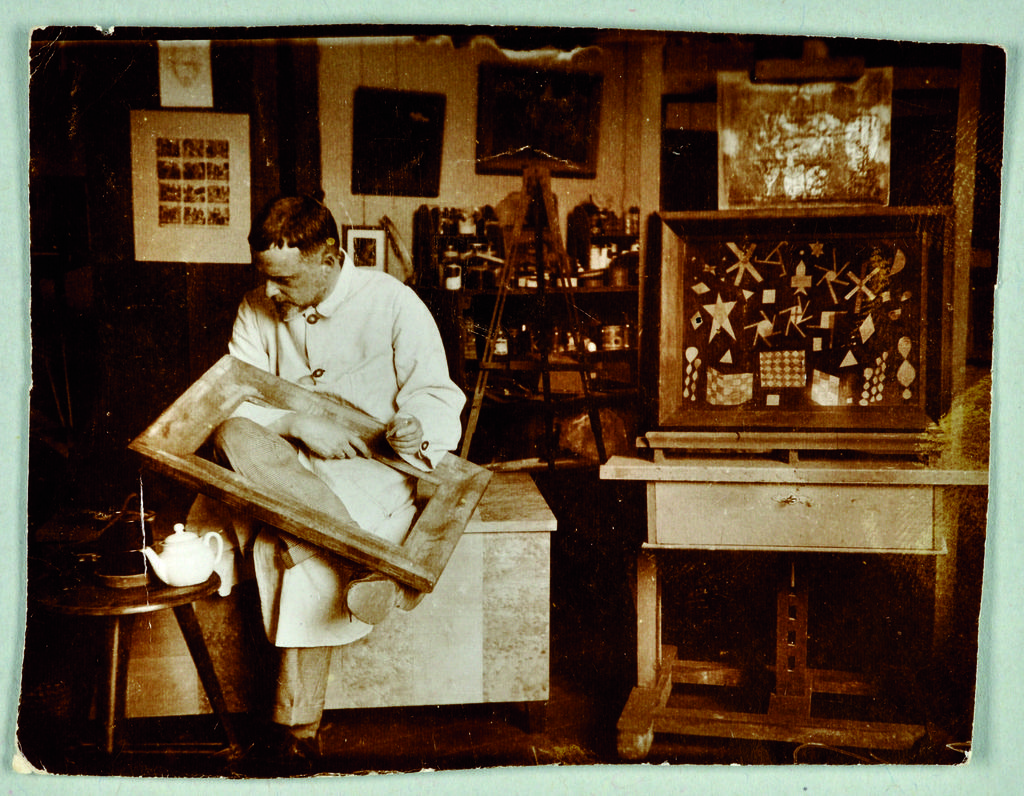Can you describe this image briefly? In this image I can see an old photograph in which I can see a person sitting and holding an object. I can see a table in front of him and on it I can see a teapot. I can see the dark background in which I can see few objects. 